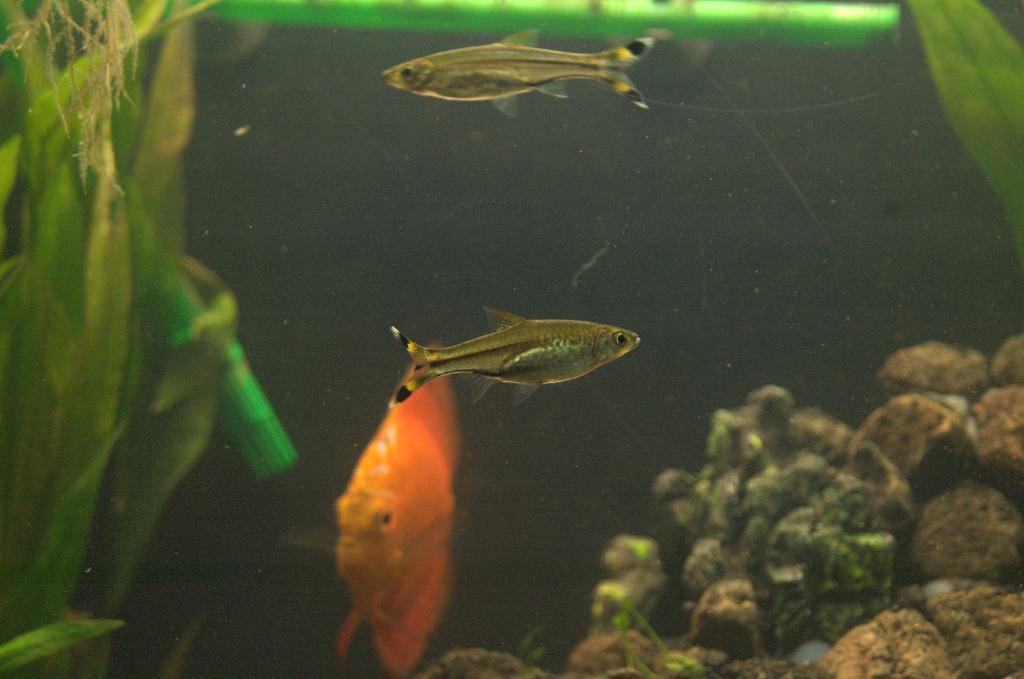How would you summarize this image in a sentence or two? In the image there are few fishes swimming in the water with plants on the left side and stones on the right side. 